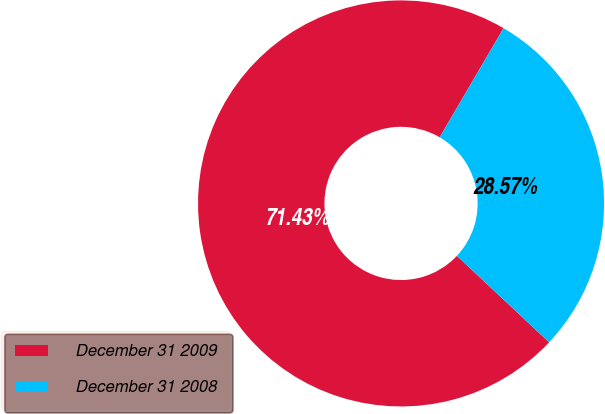<chart> <loc_0><loc_0><loc_500><loc_500><pie_chart><fcel>December 31 2009<fcel>December 31 2008<nl><fcel>71.43%<fcel>28.57%<nl></chart> 